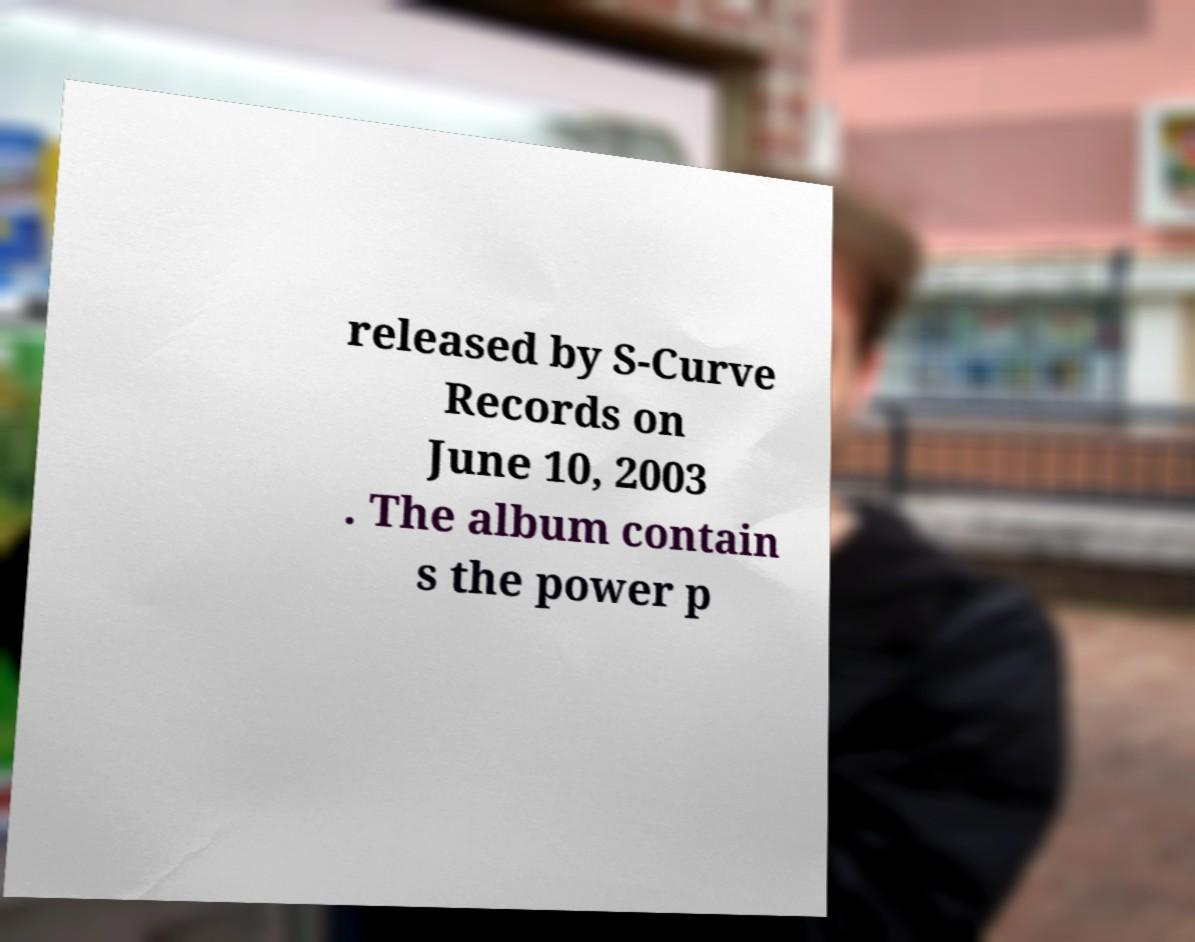Can you describe the setting of the image where the paper is being shown? The image shows a piece of paper with text, held up in an outdoor setting, possibly a street or public space, blurred in the background. This staging suggests that the information might be showcased during an event or is being revealed publicly to an audience just off-camera. 